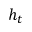Convert formula to latex. <formula><loc_0><loc_0><loc_500><loc_500>h _ { t }</formula> 